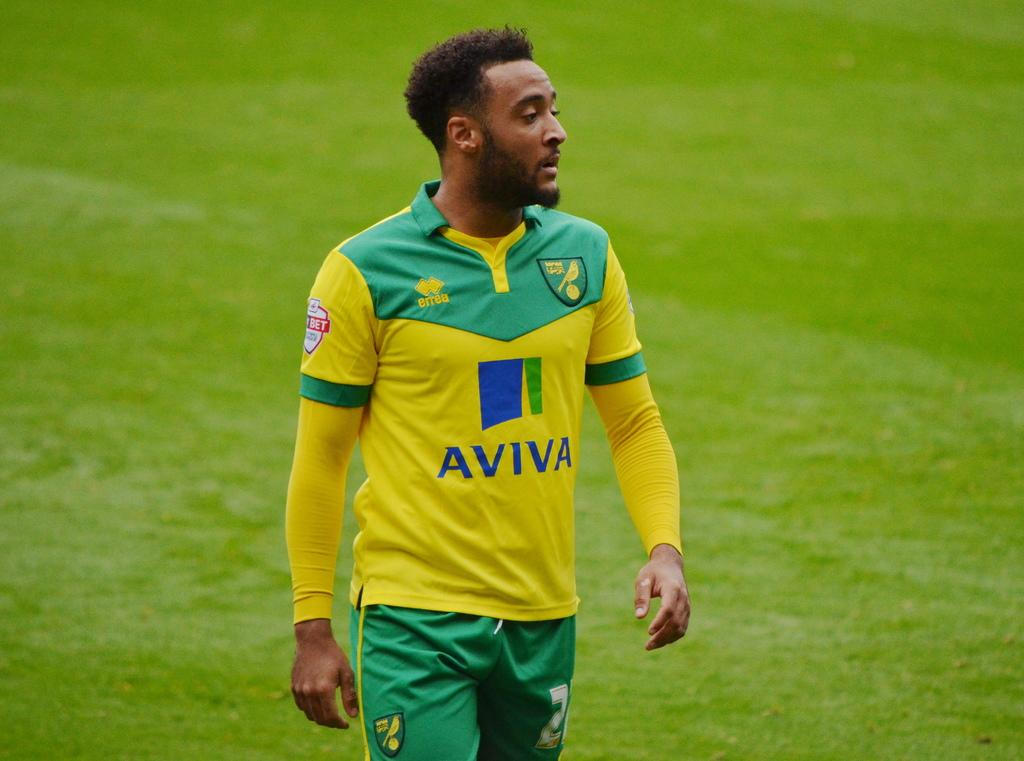<image>
Write a terse but informative summary of the picture. Athlete standing on grass wearing an "AVIVA" jersey. 